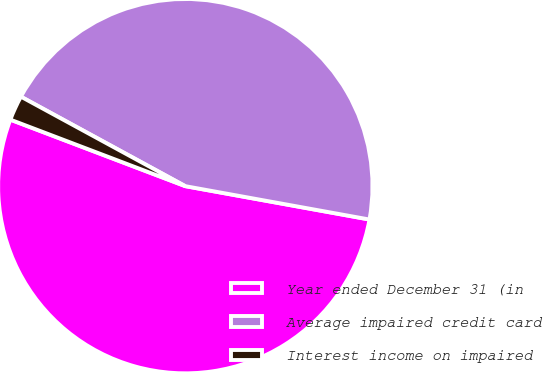Convert chart. <chart><loc_0><loc_0><loc_500><loc_500><pie_chart><fcel>Year ended December 31 (in<fcel>Average impaired credit card<fcel>Interest income on impaired<nl><fcel>52.93%<fcel>44.92%<fcel>2.15%<nl></chart> 